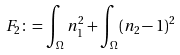Convert formula to latex. <formula><loc_0><loc_0><loc_500><loc_500>F _ { 2 } \colon = \int _ { \Omega } n _ { 1 } ^ { 2 } + \int _ { \Omega } ( n _ { 2 } - 1 ) ^ { 2 }</formula> 